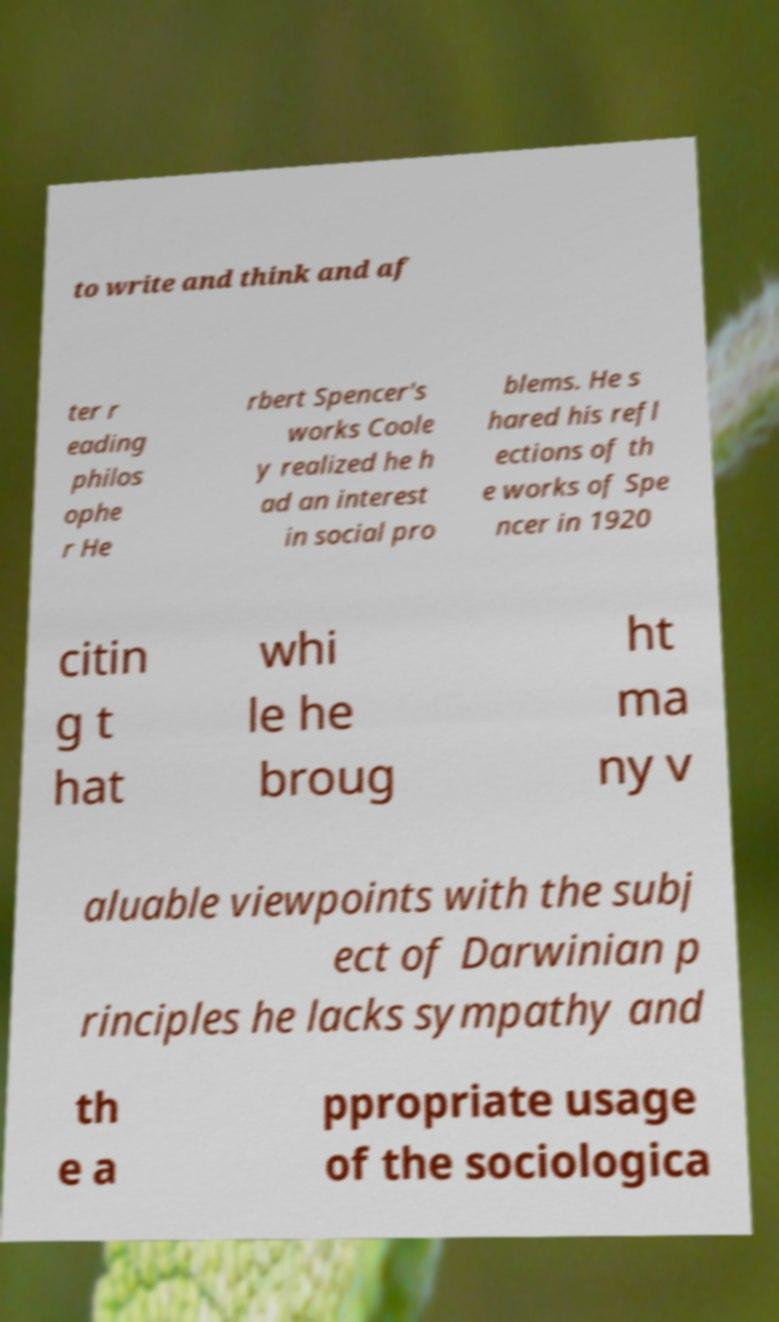Could you assist in decoding the text presented in this image and type it out clearly? to write and think and af ter r eading philos ophe r He rbert Spencer's works Coole y realized he h ad an interest in social pro blems. He s hared his refl ections of th e works of Spe ncer in 1920 citin g t hat whi le he broug ht ma ny v aluable viewpoints with the subj ect of Darwinian p rinciples he lacks sympathy and th e a ppropriate usage of the sociologica 